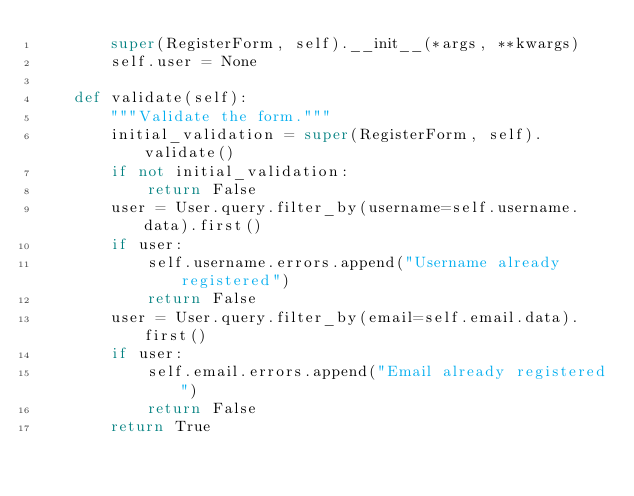Convert code to text. <code><loc_0><loc_0><loc_500><loc_500><_Python_>        super(RegisterForm, self).__init__(*args, **kwargs)
        self.user = None

    def validate(self):
        """Validate the form."""
        initial_validation = super(RegisterForm, self).validate()
        if not initial_validation:
            return False
        user = User.query.filter_by(username=self.username.data).first()
        if user:
            self.username.errors.append("Username already registered")
            return False
        user = User.query.filter_by(email=self.email.data).first()
        if user:
            self.email.errors.append("Email already registered")
            return False
        return True
</code> 